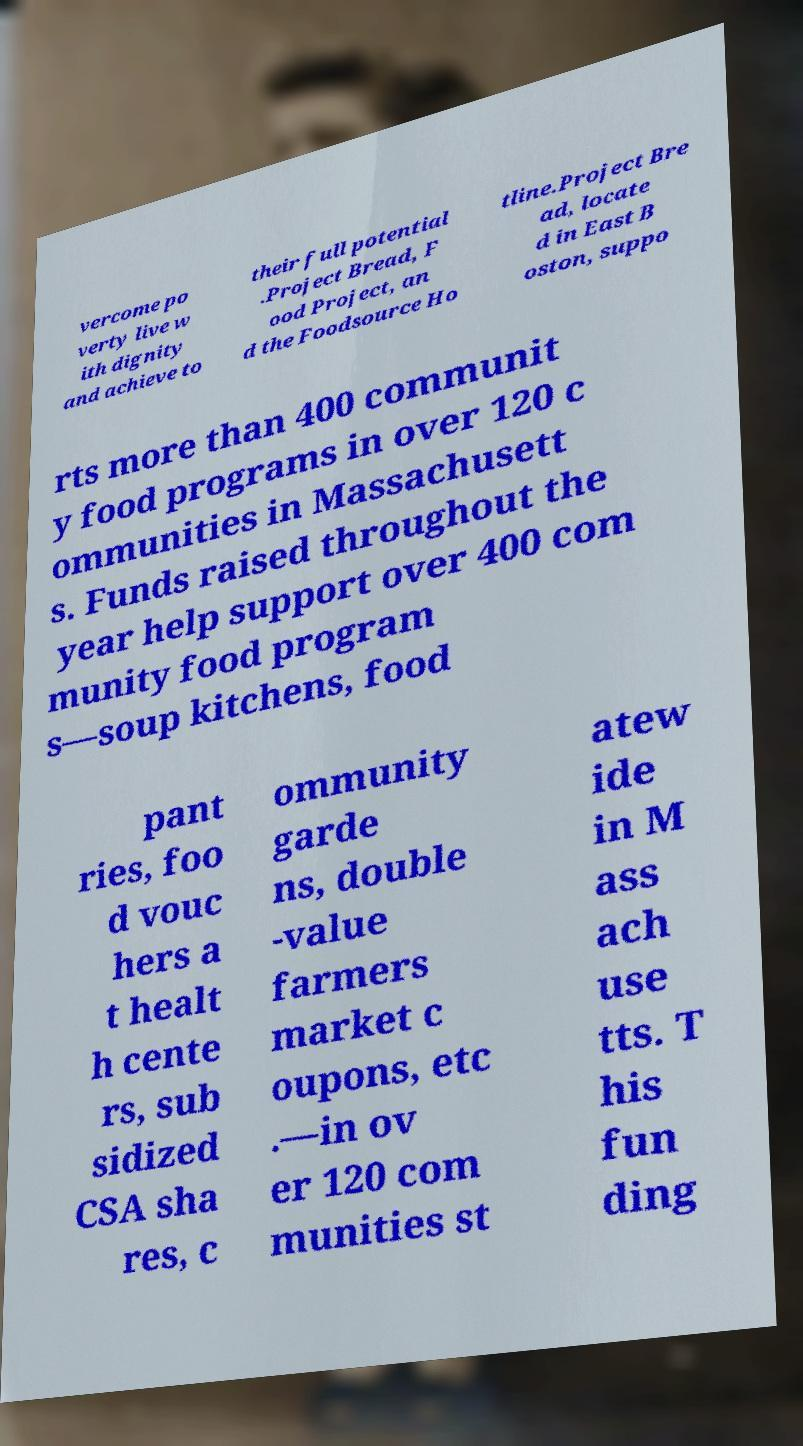Could you assist in decoding the text presented in this image and type it out clearly? vercome po verty live w ith dignity and achieve to their full potential .Project Bread, F ood Project, an d the Foodsource Ho tline.Project Bre ad, locate d in East B oston, suppo rts more than 400 communit y food programs in over 120 c ommunities in Massachusett s. Funds raised throughout the year help support over 400 com munity food program s—soup kitchens, food pant ries, foo d vouc hers a t healt h cente rs, sub sidized CSA sha res, c ommunity garde ns, double -value farmers market c oupons, etc .—in ov er 120 com munities st atew ide in M ass ach use tts. T his fun ding 